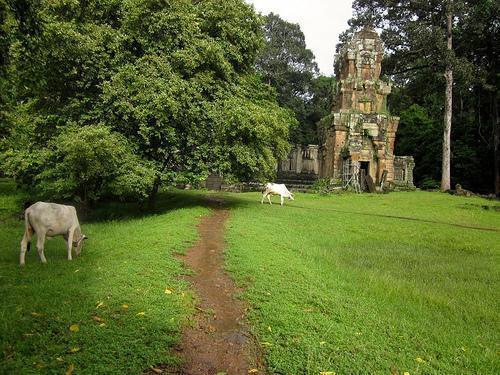How many cows are there?
Give a very brief answer. 2. 